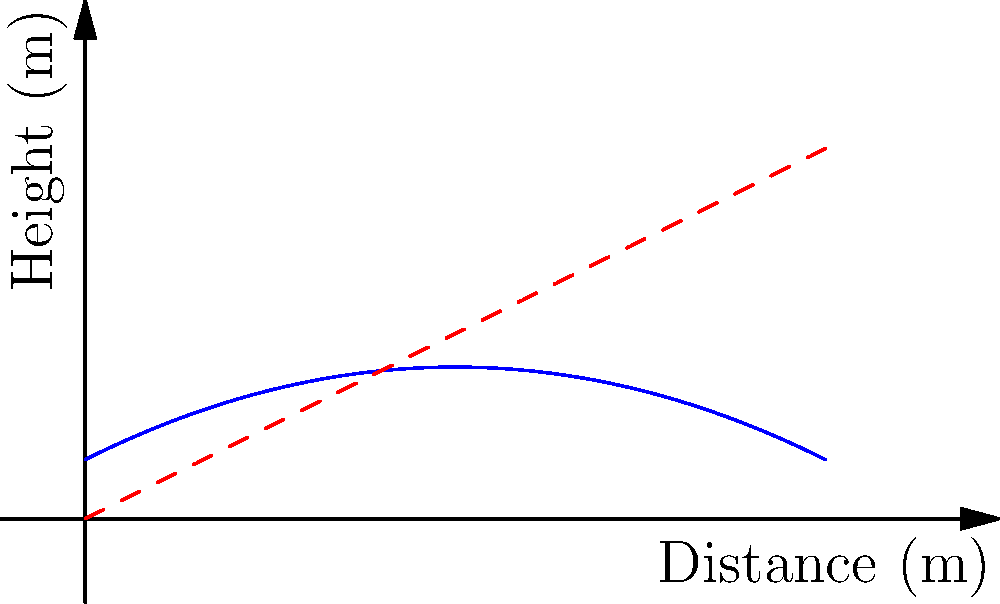In the graph above, the blue curve represents the trajectory of shrapnel from an IED, modeled by the function $f(x) = -0.02x^2 + 0.5x + 2$, where $x$ is the horizontal distance in meters and $f(x)$ is the height in meters. The red dashed line represents the line of sight from the IED. At what horizontal distance does the shrapnel reach its maximum height, and what is that maximum height? To find the maximum height of the shrapnel trajectory, we need to follow these steps:

1) The function $f(x) = -0.02x^2 + 0.5x + 2$ is a quadratic function, and its graph is a parabola.

2) For a quadratic function in the form $f(x) = ax^2 + bx + c$, the x-coordinate of the vertex (which represents the maximum or minimum point) is given by $x = -\frac{b}{2a}$.

3) In our case, $a = -0.02$ and $b = 0.5$. Let's calculate:

   $x = -\frac{0.5}{2(-0.02)} = -\frac{0.5}{-0.04} = 12.5$ meters

4) To find the maximum height, we need to evaluate $f(12.5)$:

   $f(12.5) = -0.02(12.5)^2 + 0.5(12.5) + 2$
            $= -0.02(156.25) + 6.25 + 2$
            $= -3.125 + 6.25 + 2$
            $= 5.125$ meters

Therefore, the shrapnel reaches its maximum height of 5.125 meters at a horizontal distance of 12.5 meters from the IED.
Answer: 12.5 meters, 5.125 meters 